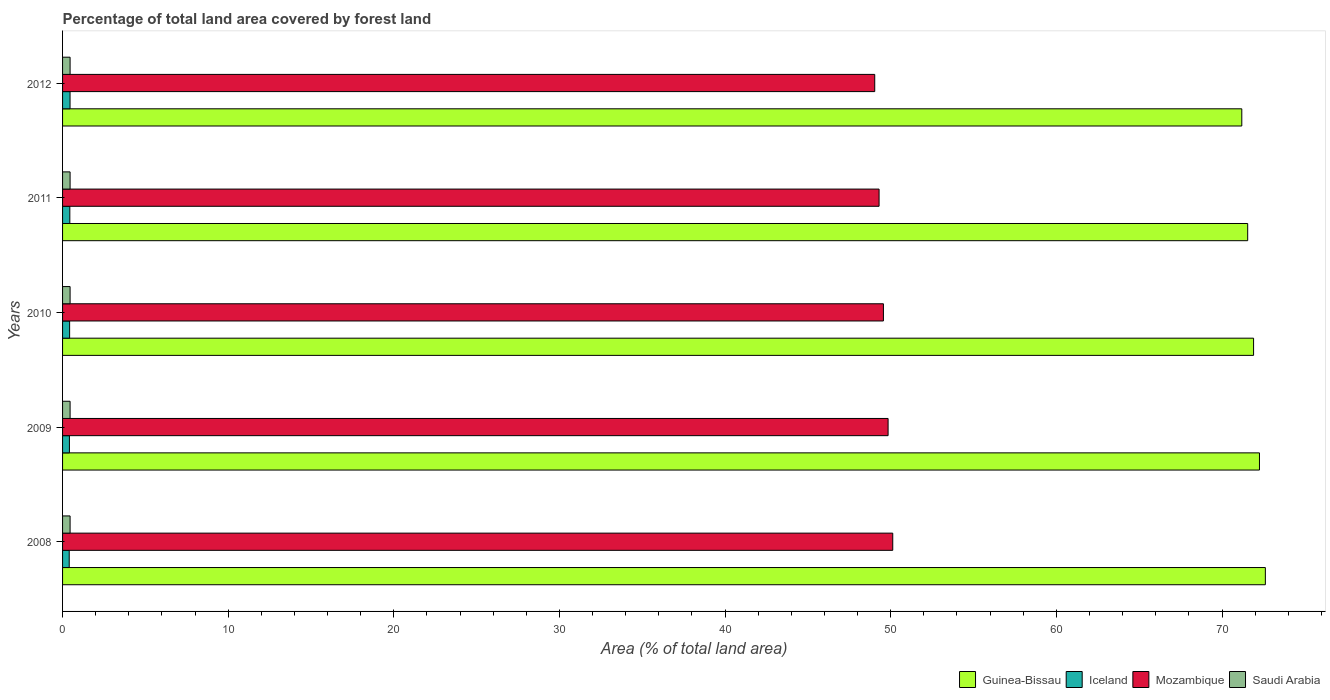How many groups of bars are there?
Offer a very short reply. 5. Are the number of bars per tick equal to the number of legend labels?
Offer a terse response. Yes. In how many cases, is the number of bars for a given year not equal to the number of legend labels?
Provide a succinct answer. 0. What is the percentage of forest land in Mozambique in 2010?
Your answer should be very brief. 49.56. Across all years, what is the maximum percentage of forest land in Iceland?
Provide a succinct answer. 0.45. Across all years, what is the minimum percentage of forest land in Saudi Arabia?
Your answer should be compact. 0.45. In which year was the percentage of forest land in Mozambique minimum?
Your response must be concise. 2012. What is the total percentage of forest land in Guinea-Bissau in the graph?
Make the answer very short. 359.53. What is the difference between the percentage of forest land in Guinea-Bissau in 2009 and the percentage of forest land in Mozambique in 2011?
Your response must be concise. 22.97. What is the average percentage of forest land in Mozambique per year?
Provide a succinct answer. 49.57. In the year 2008, what is the difference between the percentage of forest land in Mozambique and percentage of forest land in Iceland?
Provide a succinct answer. 49.72. In how many years, is the percentage of forest land in Iceland greater than 10 %?
Offer a terse response. 0. What is the ratio of the percentage of forest land in Guinea-Bissau in 2009 to that in 2011?
Offer a very short reply. 1.01. Is the percentage of forest land in Mozambique in 2011 less than that in 2012?
Your answer should be compact. No. Is the difference between the percentage of forest land in Mozambique in 2009 and 2011 greater than the difference between the percentage of forest land in Iceland in 2009 and 2011?
Your answer should be compact. Yes. What is the difference between the highest and the second highest percentage of forest land in Saudi Arabia?
Your answer should be compact. 0. What is the difference between the highest and the lowest percentage of forest land in Guinea-Bissau?
Ensure brevity in your answer.  1.42. In how many years, is the percentage of forest land in Iceland greater than the average percentage of forest land in Iceland taken over all years?
Your answer should be compact. 2. What does the 1st bar from the top in 2009 represents?
Offer a terse response. Saudi Arabia. What does the 3rd bar from the bottom in 2008 represents?
Offer a terse response. Mozambique. How many years are there in the graph?
Make the answer very short. 5. Are the values on the major ticks of X-axis written in scientific E-notation?
Ensure brevity in your answer.  No. Does the graph contain any zero values?
Provide a succinct answer. No. Does the graph contain grids?
Make the answer very short. No. How many legend labels are there?
Your response must be concise. 4. What is the title of the graph?
Keep it short and to the point. Percentage of total land area covered by forest land. Does "Uganda" appear as one of the legend labels in the graph?
Ensure brevity in your answer.  No. What is the label or title of the X-axis?
Keep it short and to the point. Area (% of total land area). What is the Area (% of total land area) of Guinea-Bissau in 2008?
Provide a short and direct response. 72.62. What is the Area (% of total land area) of Iceland in 2008?
Your answer should be compact. 0.4. What is the Area (% of total land area) of Mozambique in 2008?
Your response must be concise. 50.12. What is the Area (% of total land area) of Saudi Arabia in 2008?
Ensure brevity in your answer.  0.45. What is the Area (% of total land area) of Guinea-Bissau in 2009?
Your response must be concise. 72.26. What is the Area (% of total land area) of Iceland in 2009?
Offer a terse response. 0.41. What is the Area (% of total land area) in Mozambique in 2009?
Provide a succinct answer. 49.84. What is the Area (% of total land area) in Saudi Arabia in 2009?
Offer a very short reply. 0.45. What is the Area (% of total land area) of Guinea-Bissau in 2010?
Keep it short and to the point. 71.91. What is the Area (% of total land area) in Iceland in 2010?
Offer a very short reply. 0.43. What is the Area (% of total land area) in Mozambique in 2010?
Your response must be concise. 49.56. What is the Area (% of total land area) in Saudi Arabia in 2010?
Your answer should be compact. 0.45. What is the Area (% of total land area) in Guinea-Bissau in 2011?
Your answer should be very brief. 71.55. What is the Area (% of total land area) of Iceland in 2011?
Keep it short and to the point. 0.44. What is the Area (% of total land area) in Mozambique in 2011?
Keep it short and to the point. 49.3. What is the Area (% of total land area) in Saudi Arabia in 2011?
Make the answer very short. 0.45. What is the Area (% of total land area) of Guinea-Bissau in 2012?
Ensure brevity in your answer.  71.19. What is the Area (% of total land area) in Iceland in 2012?
Your answer should be very brief. 0.45. What is the Area (% of total land area) in Mozambique in 2012?
Offer a terse response. 49.03. What is the Area (% of total land area) of Saudi Arabia in 2012?
Your answer should be compact. 0.45. Across all years, what is the maximum Area (% of total land area) in Guinea-Bissau?
Ensure brevity in your answer.  72.62. Across all years, what is the maximum Area (% of total land area) of Iceland?
Give a very brief answer. 0.45. Across all years, what is the maximum Area (% of total land area) of Mozambique?
Offer a terse response. 50.12. Across all years, what is the maximum Area (% of total land area) of Saudi Arabia?
Make the answer very short. 0.45. Across all years, what is the minimum Area (% of total land area) in Guinea-Bissau?
Your answer should be compact. 71.19. Across all years, what is the minimum Area (% of total land area) of Iceland?
Your answer should be very brief. 0.4. Across all years, what is the minimum Area (% of total land area) of Mozambique?
Your answer should be very brief. 49.03. Across all years, what is the minimum Area (% of total land area) of Saudi Arabia?
Ensure brevity in your answer.  0.45. What is the total Area (% of total land area) of Guinea-Bissau in the graph?
Ensure brevity in your answer.  359.53. What is the total Area (% of total land area) of Iceland in the graph?
Offer a terse response. 2.13. What is the total Area (% of total land area) in Mozambique in the graph?
Keep it short and to the point. 247.85. What is the total Area (% of total land area) in Saudi Arabia in the graph?
Make the answer very short. 2.27. What is the difference between the Area (% of total land area) of Guinea-Bissau in 2008 and that in 2009?
Your response must be concise. 0.36. What is the difference between the Area (% of total land area) of Iceland in 2008 and that in 2009?
Make the answer very short. -0.01. What is the difference between the Area (% of total land area) in Mozambique in 2008 and that in 2009?
Keep it short and to the point. 0.28. What is the difference between the Area (% of total land area) in Saudi Arabia in 2008 and that in 2009?
Offer a very short reply. 0. What is the difference between the Area (% of total land area) in Guinea-Bissau in 2008 and that in 2010?
Make the answer very short. 0.71. What is the difference between the Area (% of total land area) in Iceland in 2008 and that in 2010?
Your response must be concise. -0.02. What is the difference between the Area (% of total land area) in Mozambique in 2008 and that in 2010?
Provide a short and direct response. 0.56. What is the difference between the Area (% of total land area) of Guinea-Bissau in 2008 and that in 2011?
Provide a short and direct response. 1.07. What is the difference between the Area (% of total land area) in Iceland in 2008 and that in 2011?
Keep it short and to the point. -0.04. What is the difference between the Area (% of total land area) in Mozambique in 2008 and that in 2011?
Your response must be concise. 0.83. What is the difference between the Area (% of total land area) of Guinea-Bissau in 2008 and that in 2012?
Provide a succinct answer. 1.42. What is the difference between the Area (% of total land area) in Iceland in 2008 and that in 2012?
Your answer should be compact. -0.05. What is the difference between the Area (% of total land area) of Mozambique in 2008 and that in 2012?
Your answer should be very brief. 1.09. What is the difference between the Area (% of total land area) in Guinea-Bissau in 2009 and that in 2010?
Your answer should be very brief. 0.36. What is the difference between the Area (% of total land area) of Iceland in 2009 and that in 2010?
Provide a short and direct response. -0.01. What is the difference between the Area (% of total land area) of Mozambique in 2009 and that in 2010?
Ensure brevity in your answer.  0.28. What is the difference between the Area (% of total land area) in Saudi Arabia in 2009 and that in 2010?
Ensure brevity in your answer.  0. What is the difference between the Area (% of total land area) in Guinea-Bissau in 2009 and that in 2011?
Your response must be concise. 0.71. What is the difference between the Area (% of total land area) in Iceland in 2009 and that in 2011?
Give a very brief answer. -0.03. What is the difference between the Area (% of total land area) of Mozambique in 2009 and that in 2011?
Give a very brief answer. 0.54. What is the difference between the Area (% of total land area) of Guinea-Bissau in 2009 and that in 2012?
Your answer should be compact. 1.07. What is the difference between the Area (% of total land area) of Iceland in 2009 and that in 2012?
Your response must be concise. -0.04. What is the difference between the Area (% of total land area) of Mozambique in 2009 and that in 2012?
Your response must be concise. 0.81. What is the difference between the Area (% of total land area) in Guinea-Bissau in 2010 and that in 2011?
Your answer should be compact. 0.36. What is the difference between the Area (% of total land area) in Iceland in 2010 and that in 2011?
Provide a succinct answer. -0.01. What is the difference between the Area (% of total land area) in Mozambique in 2010 and that in 2011?
Your response must be concise. 0.26. What is the difference between the Area (% of total land area) of Saudi Arabia in 2010 and that in 2011?
Make the answer very short. 0. What is the difference between the Area (% of total land area) in Guinea-Bissau in 2010 and that in 2012?
Provide a short and direct response. 0.71. What is the difference between the Area (% of total land area) of Iceland in 2010 and that in 2012?
Offer a terse response. -0.03. What is the difference between the Area (% of total land area) of Mozambique in 2010 and that in 2012?
Offer a very short reply. 0.52. What is the difference between the Area (% of total land area) in Saudi Arabia in 2010 and that in 2012?
Keep it short and to the point. 0. What is the difference between the Area (% of total land area) in Guinea-Bissau in 2011 and that in 2012?
Offer a terse response. 0.36. What is the difference between the Area (% of total land area) in Iceland in 2011 and that in 2012?
Provide a succinct answer. -0.01. What is the difference between the Area (% of total land area) in Mozambique in 2011 and that in 2012?
Provide a short and direct response. 0.26. What is the difference between the Area (% of total land area) in Saudi Arabia in 2011 and that in 2012?
Your answer should be compact. 0. What is the difference between the Area (% of total land area) in Guinea-Bissau in 2008 and the Area (% of total land area) in Iceland in 2009?
Ensure brevity in your answer.  72.2. What is the difference between the Area (% of total land area) of Guinea-Bissau in 2008 and the Area (% of total land area) of Mozambique in 2009?
Ensure brevity in your answer.  22.78. What is the difference between the Area (% of total land area) of Guinea-Bissau in 2008 and the Area (% of total land area) of Saudi Arabia in 2009?
Offer a terse response. 72.16. What is the difference between the Area (% of total land area) of Iceland in 2008 and the Area (% of total land area) of Mozambique in 2009?
Offer a terse response. -49.44. What is the difference between the Area (% of total land area) in Iceland in 2008 and the Area (% of total land area) in Saudi Arabia in 2009?
Offer a very short reply. -0.05. What is the difference between the Area (% of total land area) in Mozambique in 2008 and the Area (% of total land area) in Saudi Arabia in 2009?
Ensure brevity in your answer.  49.67. What is the difference between the Area (% of total land area) of Guinea-Bissau in 2008 and the Area (% of total land area) of Iceland in 2010?
Your answer should be compact. 72.19. What is the difference between the Area (% of total land area) of Guinea-Bissau in 2008 and the Area (% of total land area) of Mozambique in 2010?
Provide a short and direct response. 23.06. What is the difference between the Area (% of total land area) of Guinea-Bissau in 2008 and the Area (% of total land area) of Saudi Arabia in 2010?
Your answer should be very brief. 72.16. What is the difference between the Area (% of total land area) of Iceland in 2008 and the Area (% of total land area) of Mozambique in 2010?
Make the answer very short. -49.16. What is the difference between the Area (% of total land area) in Iceland in 2008 and the Area (% of total land area) in Saudi Arabia in 2010?
Ensure brevity in your answer.  -0.05. What is the difference between the Area (% of total land area) in Mozambique in 2008 and the Area (% of total land area) in Saudi Arabia in 2010?
Keep it short and to the point. 49.67. What is the difference between the Area (% of total land area) of Guinea-Bissau in 2008 and the Area (% of total land area) of Iceland in 2011?
Your answer should be compact. 72.18. What is the difference between the Area (% of total land area) of Guinea-Bissau in 2008 and the Area (% of total land area) of Mozambique in 2011?
Make the answer very short. 23.32. What is the difference between the Area (% of total land area) in Guinea-Bissau in 2008 and the Area (% of total land area) in Saudi Arabia in 2011?
Give a very brief answer. 72.16. What is the difference between the Area (% of total land area) in Iceland in 2008 and the Area (% of total land area) in Mozambique in 2011?
Give a very brief answer. -48.9. What is the difference between the Area (% of total land area) of Iceland in 2008 and the Area (% of total land area) of Saudi Arabia in 2011?
Your answer should be compact. -0.05. What is the difference between the Area (% of total land area) in Mozambique in 2008 and the Area (% of total land area) in Saudi Arabia in 2011?
Make the answer very short. 49.67. What is the difference between the Area (% of total land area) of Guinea-Bissau in 2008 and the Area (% of total land area) of Iceland in 2012?
Provide a short and direct response. 72.17. What is the difference between the Area (% of total land area) of Guinea-Bissau in 2008 and the Area (% of total land area) of Mozambique in 2012?
Provide a short and direct response. 23.58. What is the difference between the Area (% of total land area) in Guinea-Bissau in 2008 and the Area (% of total land area) in Saudi Arabia in 2012?
Offer a very short reply. 72.16. What is the difference between the Area (% of total land area) of Iceland in 2008 and the Area (% of total land area) of Mozambique in 2012?
Provide a short and direct response. -48.63. What is the difference between the Area (% of total land area) in Iceland in 2008 and the Area (% of total land area) in Saudi Arabia in 2012?
Offer a terse response. -0.05. What is the difference between the Area (% of total land area) in Mozambique in 2008 and the Area (% of total land area) in Saudi Arabia in 2012?
Offer a terse response. 49.67. What is the difference between the Area (% of total land area) of Guinea-Bissau in 2009 and the Area (% of total land area) of Iceland in 2010?
Keep it short and to the point. 71.84. What is the difference between the Area (% of total land area) in Guinea-Bissau in 2009 and the Area (% of total land area) in Mozambique in 2010?
Offer a very short reply. 22.7. What is the difference between the Area (% of total land area) of Guinea-Bissau in 2009 and the Area (% of total land area) of Saudi Arabia in 2010?
Offer a terse response. 71.81. What is the difference between the Area (% of total land area) in Iceland in 2009 and the Area (% of total land area) in Mozambique in 2010?
Provide a short and direct response. -49.15. What is the difference between the Area (% of total land area) in Iceland in 2009 and the Area (% of total land area) in Saudi Arabia in 2010?
Give a very brief answer. -0.04. What is the difference between the Area (% of total land area) of Mozambique in 2009 and the Area (% of total land area) of Saudi Arabia in 2010?
Your answer should be compact. 49.39. What is the difference between the Area (% of total land area) of Guinea-Bissau in 2009 and the Area (% of total land area) of Iceland in 2011?
Give a very brief answer. 71.82. What is the difference between the Area (% of total land area) of Guinea-Bissau in 2009 and the Area (% of total land area) of Mozambique in 2011?
Your answer should be very brief. 22.97. What is the difference between the Area (% of total land area) of Guinea-Bissau in 2009 and the Area (% of total land area) of Saudi Arabia in 2011?
Offer a terse response. 71.81. What is the difference between the Area (% of total land area) of Iceland in 2009 and the Area (% of total land area) of Mozambique in 2011?
Make the answer very short. -48.88. What is the difference between the Area (% of total land area) of Iceland in 2009 and the Area (% of total land area) of Saudi Arabia in 2011?
Keep it short and to the point. -0.04. What is the difference between the Area (% of total land area) of Mozambique in 2009 and the Area (% of total land area) of Saudi Arabia in 2011?
Provide a short and direct response. 49.39. What is the difference between the Area (% of total land area) of Guinea-Bissau in 2009 and the Area (% of total land area) of Iceland in 2012?
Offer a very short reply. 71.81. What is the difference between the Area (% of total land area) of Guinea-Bissau in 2009 and the Area (% of total land area) of Mozambique in 2012?
Your response must be concise. 23.23. What is the difference between the Area (% of total land area) in Guinea-Bissau in 2009 and the Area (% of total land area) in Saudi Arabia in 2012?
Keep it short and to the point. 71.81. What is the difference between the Area (% of total land area) in Iceland in 2009 and the Area (% of total land area) in Mozambique in 2012?
Provide a succinct answer. -48.62. What is the difference between the Area (% of total land area) in Iceland in 2009 and the Area (% of total land area) in Saudi Arabia in 2012?
Keep it short and to the point. -0.04. What is the difference between the Area (% of total land area) in Mozambique in 2009 and the Area (% of total land area) in Saudi Arabia in 2012?
Ensure brevity in your answer.  49.39. What is the difference between the Area (% of total land area) of Guinea-Bissau in 2010 and the Area (% of total land area) of Iceland in 2011?
Ensure brevity in your answer.  71.47. What is the difference between the Area (% of total land area) of Guinea-Bissau in 2010 and the Area (% of total land area) of Mozambique in 2011?
Provide a short and direct response. 22.61. What is the difference between the Area (% of total land area) in Guinea-Bissau in 2010 and the Area (% of total land area) in Saudi Arabia in 2011?
Provide a short and direct response. 71.45. What is the difference between the Area (% of total land area) in Iceland in 2010 and the Area (% of total land area) in Mozambique in 2011?
Offer a terse response. -48.87. What is the difference between the Area (% of total land area) of Iceland in 2010 and the Area (% of total land area) of Saudi Arabia in 2011?
Your answer should be very brief. -0.03. What is the difference between the Area (% of total land area) in Mozambique in 2010 and the Area (% of total land area) in Saudi Arabia in 2011?
Your response must be concise. 49.1. What is the difference between the Area (% of total land area) of Guinea-Bissau in 2010 and the Area (% of total land area) of Iceland in 2012?
Your response must be concise. 71.45. What is the difference between the Area (% of total land area) in Guinea-Bissau in 2010 and the Area (% of total land area) in Mozambique in 2012?
Ensure brevity in your answer.  22.87. What is the difference between the Area (% of total land area) in Guinea-Bissau in 2010 and the Area (% of total land area) in Saudi Arabia in 2012?
Your answer should be compact. 71.45. What is the difference between the Area (% of total land area) in Iceland in 2010 and the Area (% of total land area) in Mozambique in 2012?
Make the answer very short. -48.61. What is the difference between the Area (% of total land area) in Iceland in 2010 and the Area (% of total land area) in Saudi Arabia in 2012?
Ensure brevity in your answer.  -0.03. What is the difference between the Area (% of total land area) in Mozambique in 2010 and the Area (% of total land area) in Saudi Arabia in 2012?
Ensure brevity in your answer.  49.1. What is the difference between the Area (% of total land area) of Guinea-Bissau in 2011 and the Area (% of total land area) of Iceland in 2012?
Offer a terse response. 71.1. What is the difference between the Area (% of total land area) of Guinea-Bissau in 2011 and the Area (% of total land area) of Mozambique in 2012?
Make the answer very short. 22.52. What is the difference between the Area (% of total land area) in Guinea-Bissau in 2011 and the Area (% of total land area) in Saudi Arabia in 2012?
Offer a terse response. 71.1. What is the difference between the Area (% of total land area) of Iceland in 2011 and the Area (% of total land area) of Mozambique in 2012?
Make the answer very short. -48.59. What is the difference between the Area (% of total land area) of Iceland in 2011 and the Area (% of total land area) of Saudi Arabia in 2012?
Provide a short and direct response. -0.02. What is the difference between the Area (% of total land area) in Mozambique in 2011 and the Area (% of total land area) in Saudi Arabia in 2012?
Ensure brevity in your answer.  48.84. What is the average Area (% of total land area) of Guinea-Bissau per year?
Ensure brevity in your answer.  71.91. What is the average Area (% of total land area) in Iceland per year?
Your answer should be very brief. 0.43. What is the average Area (% of total land area) of Mozambique per year?
Provide a succinct answer. 49.57. What is the average Area (% of total land area) in Saudi Arabia per year?
Offer a terse response. 0.45. In the year 2008, what is the difference between the Area (% of total land area) in Guinea-Bissau and Area (% of total land area) in Iceland?
Make the answer very short. 72.22. In the year 2008, what is the difference between the Area (% of total land area) of Guinea-Bissau and Area (% of total land area) of Mozambique?
Offer a very short reply. 22.5. In the year 2008, what is the difference between the Area (% of total land area) of Guinea-Bissau and Area (% of total land area) of Saudi Arabia?
Provide a succinct answer. 72.16. In the year 2008, what is the difference between the Area (% of total land area) of Iceland and Area (% of total land area) of Mozambique?
Keep it short and to the point. -49.72. In the year 2008, what is the difference between the Area (% of total land area) of Iceland and Area (% of total land area) of Saudi Arabia?
Your response must be concise. -0.05. In the year 2008, what is the difference between the Area (% of total land area) of Mozambique and Area (% of total land area) of Saudi Arabia?
Make the answer very short. 49.67. In the year 2009, what is the difference between the Area (% of total land area) in Guinea-Bissau and Area (% of total land area) in Iceland?
Ensure brevity in your answer.  71.85. In the year 2009, what is the difference between the Area (% of total land area) in Guinea-Bissau and Area (% of total land area) in Mozambique?
Provide a short and direct response. 22.42. In the year 2009, what is the difference between the Area (% of total land area) of Guinea-Bissau and Area (% of total land area) of Saudi Arabia?
Your answer should be compact. 71.81. In the year 2009, what is the difference between the Area (% of total land area) in Iceland and Area (% of total land area) in Mozambique?
Keep it short and to the point. -49.43. In the year 2009, what is the difference between the Area (% of total land area) of Iceland and Area (% of total land area) of Saudi Arabia?
Offer a terse response. -0.04. In the year 2009, what is the difference between the Area (% of total land area) in Mozambique and Area (% of total land area) in Saudi Arabia?
Offer a terse response. 49.39. In the year 2010, what is the difference between the Area (% of total land area) in Guinea-Bissau and Area (% of total land area) in Iceland?
Your answer should be very brief. 71.48. In the year 2010, what is the difference between the Area (% of total land area) of Guinea-Bissau and Area (% of total land area) of Mozambique?
Give a very brief answer. 22.35. In the year 2010, what is the difference between the Area (% of total land area) of Guinea-Bissau and Area (% of total land area) of Saudi Arabia?
Keep it short and to the point. 71.45. In the year 2010, what is the difference between the Area (% of total land area) of Iceland and Area (% of total land area) of Mozambique?
Make the answer very short. -49.13. In the year 2010, what is the difference between the Area (% of total land area) in Iceland and Area (% of total land area) in Saudi Arabia?
Your response must be concise. -0.03. In the year 2010, what is the difference between the Area (% of total land area) of Mozambique and Area (% of total land area) of Saudi Arabia?
Give a very brief answer. 49.1. In the year 2011, what is the difference between the Area (% of total land area) of Guinea-Bissau and Area (% of total land area) of Iceland?
Your answer should be compact. 71.11. In the year 2011, what is the difference between the Area (% of total land area) in Guinea-Bissau and Area (% of total land area) in Mozambique?
Make the answer very short. 22.25. In the year 2011, what is the difference between the Area (% of total land area) in Guinea-Bissau and Area (% of total land area) in Saudi Arabia?
Keep it short and to the point. 71.1. In the year 2011, what is the difference between the Area (% of total land area) of Iceland and Area (% of total land area) of Mozambique?
Offer a very short reply. -48.86. In the year 2011, what is the difference between the Area (% of total land area) of Iceland and Area (% of total land area) of Saudi Arabia?
Keep it short and to the point. -0.02. In the year 2011, what is the difference between the Area (% of total land area) in Mozambique and Area (% of total land area) in Saudi Arabia?
Your response must be concise. 48.84. In the year 2012, what is the difference between the Area (% of total land area) of Guinea-Bissau and Area (% of total land area) of Iceland?
Ensure brevity in your answer.  70.74. In the year 2012, what is the difference between the Area (% of total land area) of Guinea-Bissau and Area (% of total land area) of Mozambique?
Provide a succinct answer. 22.16. In the year 2012, what is the difference between the Area (% of total land area) of Guinea-Bissau and Area (% of total land area) of Saudi Arabia?
Your answer should be compact. 70.74. In the year 2012, what is the difference between the Area (% of total land area) in Iceland and Area (% of total land area) in Mozambique?
Give a very brief answer. -48.58. In the year 2012, what is the difference between the Area (% of total land area) in Iceland and Area (% of total land area) in Saudi Arabia?
Provide a short and direct response. -0. In the year 2012, what is the difference between the Area (% of total land area) in Mozambique and Area (% of total land area) in Saudi Arabia?
Give a very brief answer. 48.58. What is the ratio of the Area (% of total land area) in Guinea-Bissau in 2008 to that in 2009?
Your answer should be compact. 1. What is the ratio of the Area (% of total land area) of Iceland in 2008 to that in 2009?
Provide a short and direct response. 0.97. What is the ratio of the Area (% of total land area) of Mozambique in 2008 to that in 2009?
Ensure brevity in your answer.  1.01. What is the ratio of the Area (% of total land area) in Saudi Arabia in 2008 to that in 2009?
Give a very brief answer. 1. What is the ratio of the Area (% of total land area) in Guinea-Bissau in 2008 to that in 2010?
Provide a short and direct response. 1.01. What is the ratio of the Area (% of total land area) of Iceland in 2008 to that in 2010?
Provide a succinct answer. 0.94. What is the ratio of the Area (% of total land area) in Mozambique in 2008 to that in 2010?
Your answer should be very brief. 1.01. What is the ratio of the Area (% of total land area) of Guinea-Bissau in 2008 to that in 2011?
Ensure brevity in your answer.  1.01. What is the ratio of the Area (% of total land area) of Iceland in 2008 to that in 2011?
Keep it short and to the point. 0.91. What is the ratio of the Area (% of total land area) in Mozambique in 2008 to that in 2011?
Provide a succinct answer. 1.02. What is the ratio of the Area (% of total land area) in Saudi Arabia in 2008 to that in 2011?
Your response must be concise. 1. What is the ratio of the Area (% of total land area) in Iceland in 2008 to that in 2012?
Offer a terse response. 0.89. What is the ratio of the Area (% of total land area) in Mozambique in 2008 to that in 2012?
Your answer should be compact. 1.02. What is the ratio of the Area (% of total land area) in Saudi Arabia in 2008 to that in 2012?
Offer a terse response. 1. What is the ratio of the Area (% of total land area) in Guinea-Bissau in 2009 to that in 2010?
Your answer should be very brief. 1. What is the ratio of the Area (% of total land area) in Mozambique in 2009 to that in 2010?
Your answer should be very brief. 1.01. What is the ratio of the Area (% of total land area) of Guinea-Bissau in 2009 to that in 2011?
Offer a terse response. 1.01. What is the ratio of the Area (% of total land area) of Iceland in 2009 to that in 2011?
Make the answer very short. 0.94. What is the ratio of the Area (% of total land area) in Guinea-Bissau in 2009 to that in 2012?
Make the answer very short. 1.01. What is the ratio of the Area (% of total land area) of Iceland in 2009 to that in 2012?
Offer a very short reply. 0.92. What is the ratio of the Area (% of total land area) in Mozambique in 2009 to that in 2012?
Offer a terse response. 1.02. What is the ratio of the Area (% of total land area) in Saudi Arabia in 2009 to that in 2012?
Provide a succinct answer. 1. What is the ratio of the Area (% of total land area) of Iceland in 2010 to that in 2011?
Provide a short and direct response. 0.97. What is the ratio of the Area (% of total land area) in Saudi Arabia in 2010 to that in 2011?
Give a very brief answer. 1. What is the ratio of the Area (% of total land area) in Guinea-Bissau in 2010 to that in 2012?
Your answer should be very brief. 1.01. What is the ratio of the Area (% of total land area) in Iceland in 2010 to that in 2012?
Your answer should be compact. 0.94. What is the ratio of the Area (% of total land area) in Mozambique in 2010 to that in 2012?
Your answer should be very brief. 1.01. What is the ratio of the Area (% of total land area) in Iceland in 2011 to that in 2012?
Make the answer very short. 0.97. What is the ratio of the Area (% of total land area) of Mozambique in 2011 to that in 2012?
Ensure brevity in your answer.  1.01. What is the ratio of the Area (% of total land area) of Saudi Arabia in 2011 to that in 2012?
Your answer should be very brief. 1. What is the difference between the highest and the second highest Area (% of total land area) in Guinea-Bissau?
Your answer should be compact. 0.36. What is the difference between the highest and the second highest Area (% of total land area) in Iceland?
Keep it short and to the point. 0.01. What is the difference between the highest and the second highest Area (% of total land area) of Mozambique?
Your answer should be very brief. 0.28. What is the difference between the highest and the second highest Area (% of total land area) of Saudi Arabia?
Your answer should be very brief. 0. What is the difference between the highest and the lowest Area (% of total land area) of Guinea-Bissau?
Ensure brevity in your answer.  1.42. What is the difference between the highest and the lowest Area (% of total land area) in Iceland?
Your answer should be very brief. 0.05. What is the difference between the highest and the lowest Area (% of total land area) of Mozambique?
Make the answer very short. 1.09. What is the difference between the highest and the lowest Area (% of total land area) in Saudi Arabia?
Your answer should be compact. 0. 